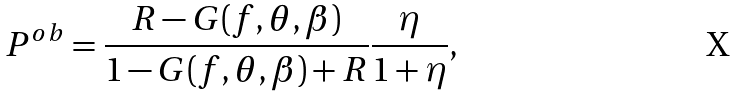<formula> <loc_0><loc_0><loc_500><loc_500>P ^ { o b } = { \frac { R - G ( f , \theta , \beta ) } { 1 - G ( f , \theta , \beta ) + R } } { \frac { \eta } { 1 + \eta } } ,</formula> 